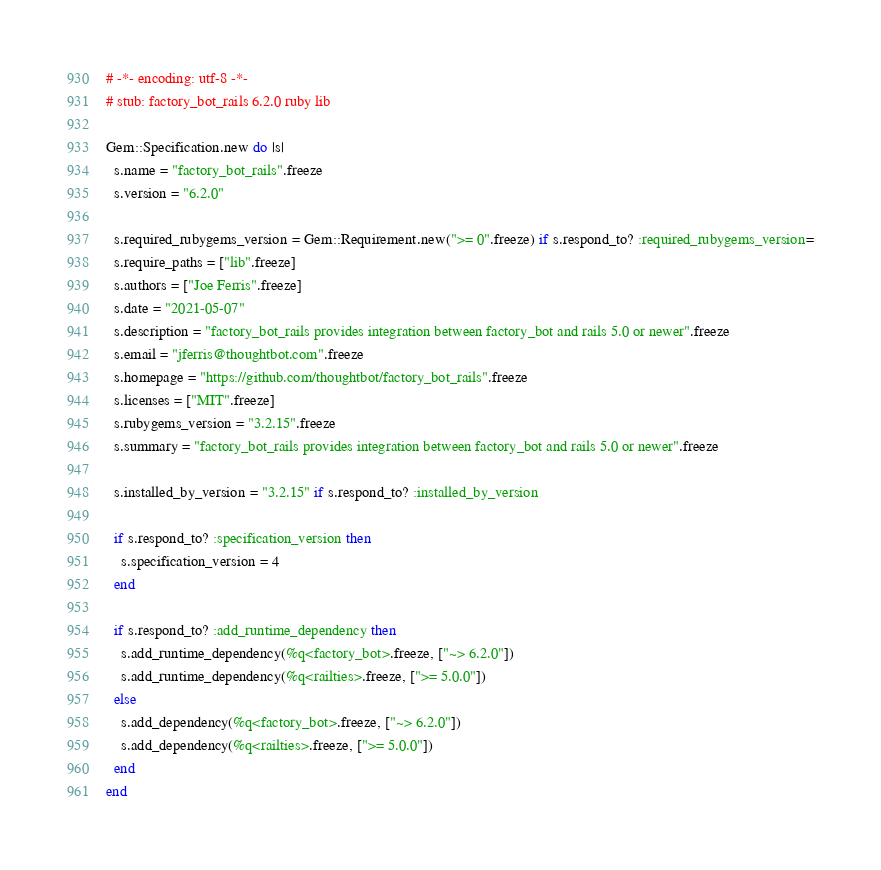Convert code to text. <code><loc_0><loc_0><loc_500><loc_500><_Ruby_># -*- encoding: utf-8 -*-
# stub: factory_bot_rails 6.2.0 ruby lib

Gem::Specification.new do |s|
  s.name = "factory_bot_rails".freeze
  s.version = "6.2.0"

  s.required_rubygems_version = Gem::Requirement.new(">= 0".freeze) if s.respond_to? :required_rubygems_version=
  s.require_paths = ["lib".freeze]
  s.authors = ["Joe Ferris".freeze]
  s.date = "2021-05-07"
  s.description = "factory_bot_rails provides integration between factory_bot and rails 5.0 or newer".freeze
  s.email = "jferris@thoughtbot.com".freeze
  s.homepage = "https://github.com/thoughtbot/factory_bot_rails".freeze
  s.licenses = ["MIT".freeze]
  s.rubygems_version = "3.2.15".freeze
  s.summary = "factory_bot_rails provides integration between factory_bot and rails 5.0 or newer".freeze

  s.installed_by_version = "3.2.15" if s.respond_to? :installed_by_version

  if s.respond_to? :specification_version then
    s.specification_version = 4
  end

  if s.respond_to? :add_runtime_dependency then
    s.add_runtime_dependency(%q<factory_bot>.freeze, ["~> 6.2.0"])
    s.add_runtime_dependency(%q<railties>.freeze, [">= 5.0.0"])
  else
    s.add_dependency(%q<factory_bot>.freeze, ["~> 6.2.0"])
    s.add_dependency(%q<railties>.freeze, [">= 5.0.0"])
  end
end
</code> 